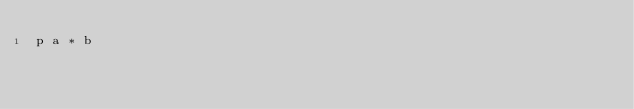<code> <loc_0><loc_0><loc_500><loc_500><_Crystal_>p a * b
</code> 